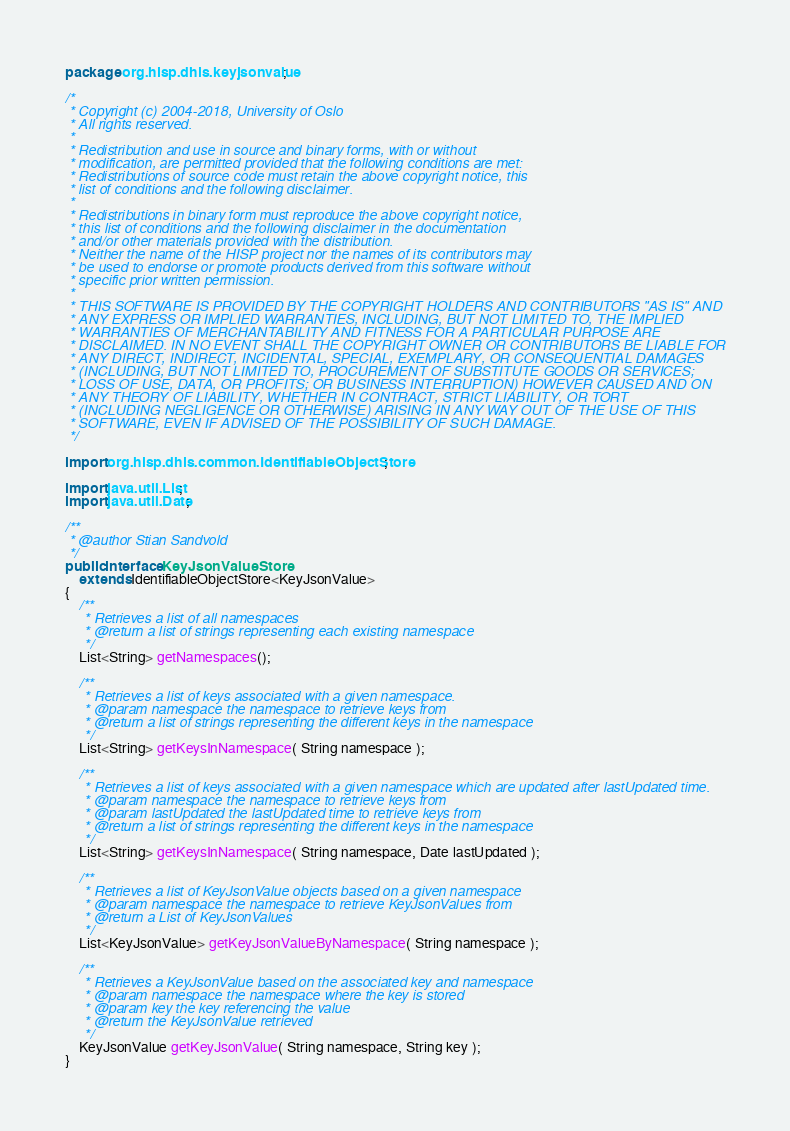Convert code to text. <code><loc_0><loc_0><loc_500><loc_500><_Java_>package org.hisp.dhis.keyjsonvalue;

/*
 * Copyright (c) 2004-2018, University of Oslo
 * All rights reserved.
 *
 * Redistribution and use in source and binary forms, with or without
 * modification, are permitted provided that the following conditions are met:
 * Redistributions of source code must retain the above copyright notice, this
 * list of conditions and the following disclaimer.
 *
 * Redistributions in binary form must reproduce the above copyright notice,
 * this list of conditions and the following disclaimer in the documentation
 * and/or other materials provided with the distribution.
 * Neither the name of the HISP project nor the names of its contributors may
 * be used to endorse or promote products derived from this software without
 * specific prior written permission.
 *
 * THIS SOFTWARE IS PROVIDED BY THE COPYRIGHT HOLDERS AND CONTRIBUTORS "AS IS" AND
 * ANY EXPRESS OR IMPLIED WARRANTIES, INCLUDING, BUT NOT LIMITED TO, THE IMPLIED
 * WARRANTIES OF MERCHANTABILITY AND FITNESS FOR A PARTICULAR PURPOSE ARE
 * DISCLAIMED. IN NO EVENT SHALL THE COPYRIGHT OWNER OR CONTRIBUTORS BE LIABLE FOR
 * ANY DIRECT, INDIRECT, INCIDENTAL, SPECIAL, EXEMPLARY, OR CONSEQUENTIAL DAMAGES
 * (INCLUDING, BUT NOT LIMITED TO, PROCUREMENT OF SUBSTITUTE GOODS OR SERVICES;
 * LOSS OF USE, DATA, OR PROFITS; OR BUSINESS INTERRUPTION) HOWEVER CAUSED AND ON
 * ANY THEORY OF LIABILITY, WHETHER IN CONTRACT, STRICT LIABILITY, OR TORT
 * (INCLUDING NEGLIGENCE OR OTHERWISE) ARISING IN ANY WAY OUT OF THE USE OF THIS
 * SOFTWARE, EVEN IF ADVISED OF THE POSSIBILITY OF SUCH DAMAGE.
 */

import org.hisp.dhis.common.IdentifiableObjectStore;

import java.util.List;
import java.util.Date;

/**
 * @author Stian Sandvold
 */
public interface KeyJsonValueStore
    extends IdentifiableObjectStore<KeyJsonValue>
{
    /**
     * Retrieves a list of all namespaces
     * @return a list of strings representing each existing namespace
     */
    List<String> getNamespaces();

    /**
     * Retrieves a list of keys associated with a given namespace.
     * @param namespace the namespace to retrieve keys from
     * @return a list of strings representing the different keys in the namespace
     */
    List<String> getKeysInNamespace( String namespace );

    /**
     * Retrieves a list of keys associated with a given namespace which are updated after lastUpdated time.
     * @param namespace the namespace to retrieve keys from
     * @param lastUpdated the lastUpdated time to retrieve keys from
     * @return a list of strings representing the different keys in the namespace
     */
    List<String> getKeysInNamespace( String namespace, Date lastUpdated );

    /**
     * Retrieves a list of KeyJsonValue objects based on a given namespace
     * @param namespace the namespace to retrieve KeyJsonValues from
     * @return a List of KeyJsonValues
     */
    List<KeyJsonValue> getKeyJsonValueByNamespace( String namespace );

    /**
     * Retrieves a KeyJsonValue based on the associated key and namespace
     * @param namespace the namespace where the key is stored
     * @param key the key referencing the value
     * @return the KeyJsonValue retrieved
     */
    KeyJsonValue getKeyJsonValue( String namespace, String key );
}
</code> 